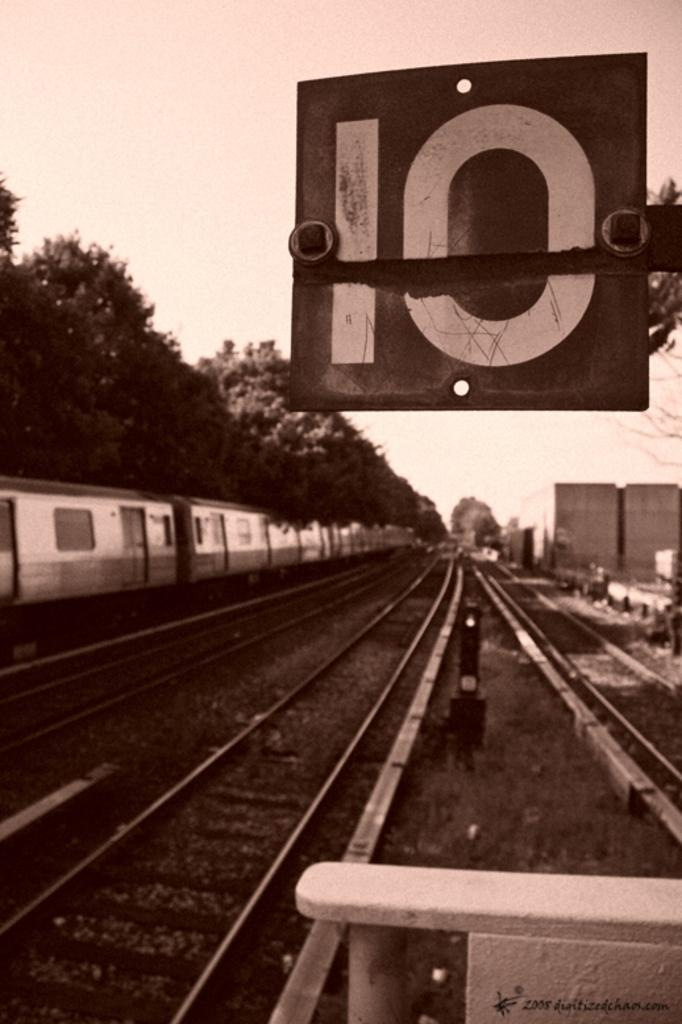<image>
Share a concise interpretation of the image provided. A sepia toned image of a railroad track with a sign stating that it is track 10. 